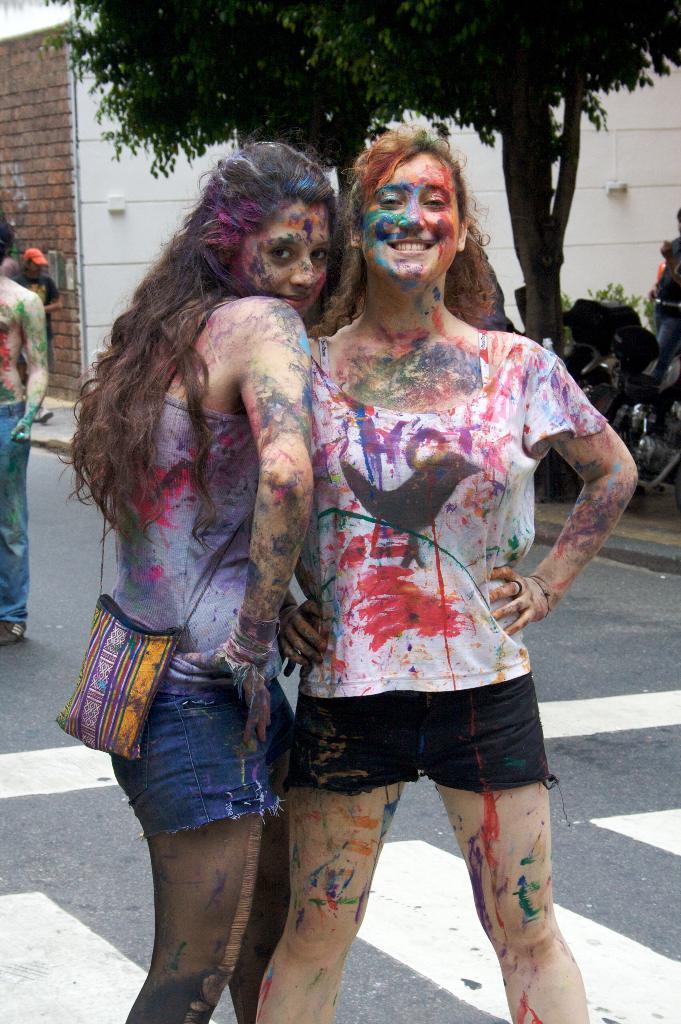How would you summarize this image in a sentence or two? In this picture there are two girls in the center of the image, there are colors on their bodies and there are other people, a trees, a bike and a wall in the background area of the image. 